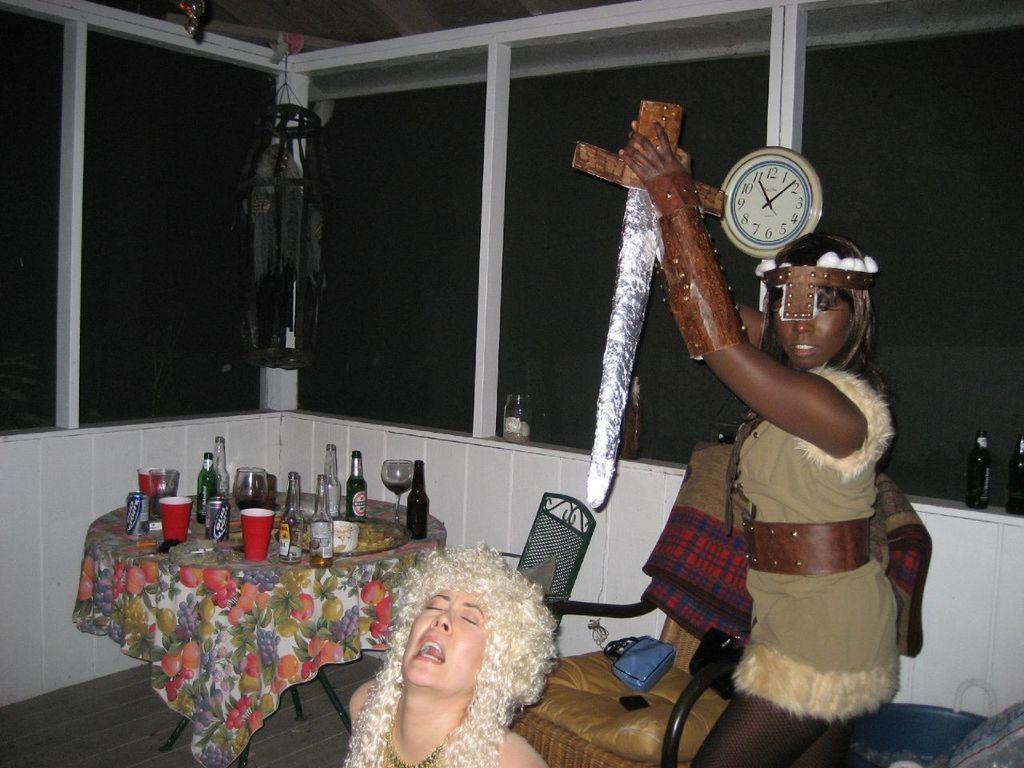What brand is on the beer cans?
Provide a short and direct response. Bud light. What time does the clock say it is?
Your response must be concise. 11:10. 